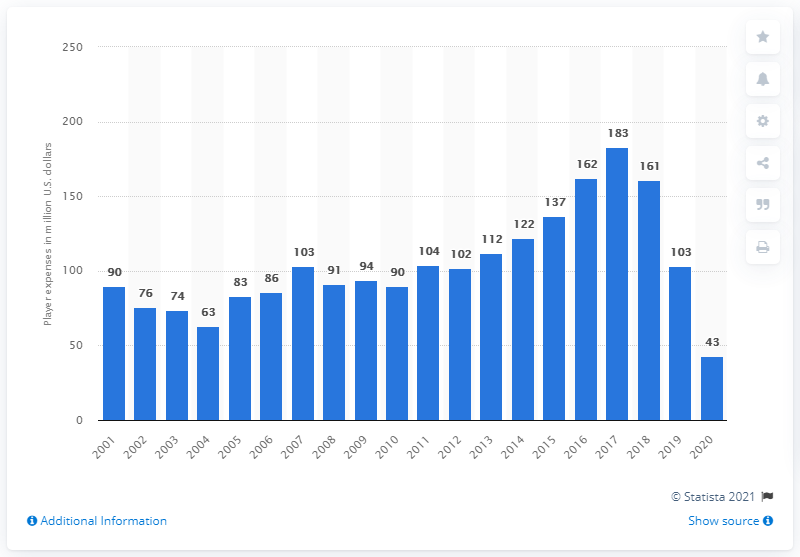Highlight a few significant elements in this photo. The payroll of the Baltimore Orioles in 2020 was approximately 43 million dollars. 